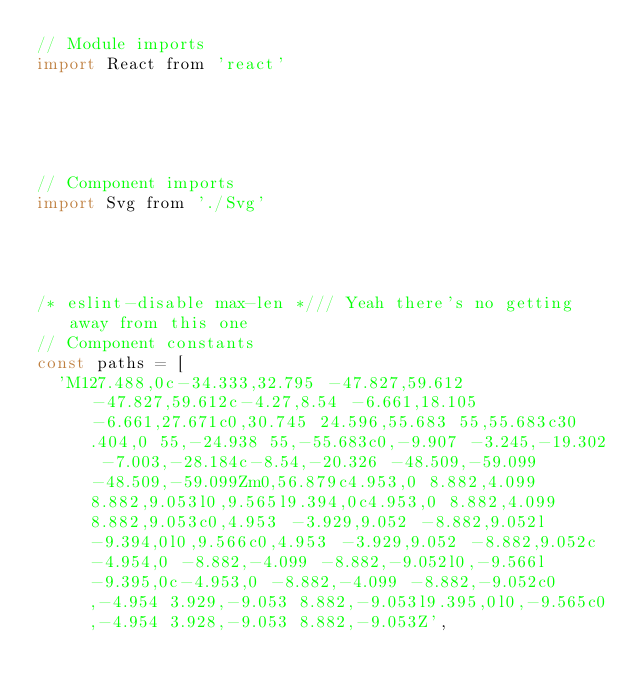<code> <loc_0><loc_0><loc_500><loc_500><_JavaScript_>// Module imports
import React from 'react'





// Component imports
import Svg from './Svg'




/* eslint-disable max-len */// Yeah there's no getting away from this one
// Component constants
const paths = [
  'M127.488,0c-34.333,32.795 -47.827,59.612 -47.827,59.612c-4.27,8.54 -6.661,18.105 -6.661,27.671c0,30.745 24.596,55.683 55,55.683c30.404,0 55,-24.938 55,-55.683c0,-9.907 -3.245,-19.302 -7.003,-28.184c-8.54,-20.326 -48.509,-59.099 -48.509,-59.099Zm0,56.879c4.953,0 8.882,4.099 8.882,9.053l0,9.565l9.394,0c4.953,0 8.882,4.099 8.882,9.053c0,4.953 -3.929,9.052 -8.882,9.052l-9.394,0l0,9.566c0,4.953 -3.929,9.052 -8.882,9.052c-4.954,0 -8.882,-4.099 -8.882,-9.052l0,-9.566l-9.395,0c-4.953,0 -8.882,-4.099 -8.882,-9.052c0,-4.954 3.929,-9.053 8.882,-9.053l9.395,0l0,-9.565c0,-4.954 3.928,-9.053 8.882,-9.053Z',</code> 